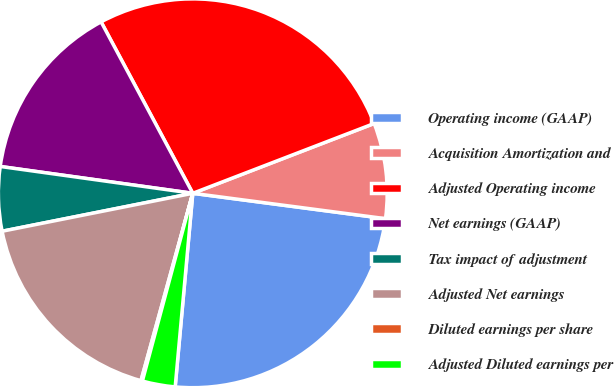<chart> <loc_0><loc_0><loc_500><loc_500><pie_chart><fcel>Operating income (GAAP)<fcel>Acquisition Amortization and<fcel>Adjusted Operating income<fcel>Net earnings (GAAP)<fcel>Tax impact of adjustment<fcel>Adjusted Net earnings<fcel>Diluted earnings per share<fcel>Adjusted Diluted earnings per<nl><fcel>24.36%<fcel>7.93%<fcel>26.97%<fcel>14.98%<fcel>5.33%<fcel>17.58%<fcel>0.12%<fcel>2.73%<nl></chart> 